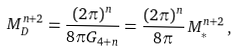Convert formula to latex. <formula><loc_0><loc_0><loc_500><loc_500>M _ { D } ^ { n + 2 } = \frac { ( 2 \pi ) ^ { n } } { 8 \pi G _ { 4 + n } } = \frac { ( 2 \pi ) ^ { n } } { 8 \pi } \, M ^ { n + 2 } _ { * } \, ,</formula> 